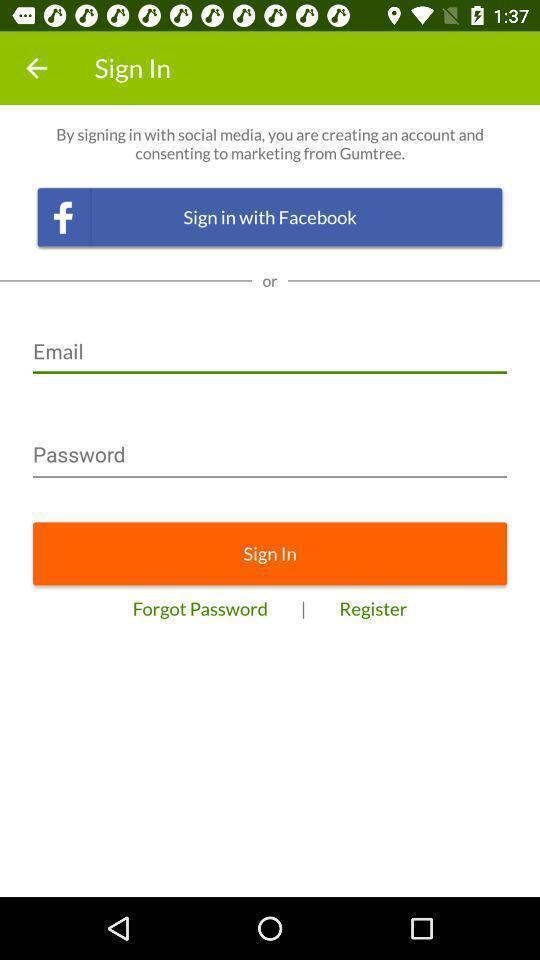Describe the visual elements of this screenshot. Signin page of a shopping application. 